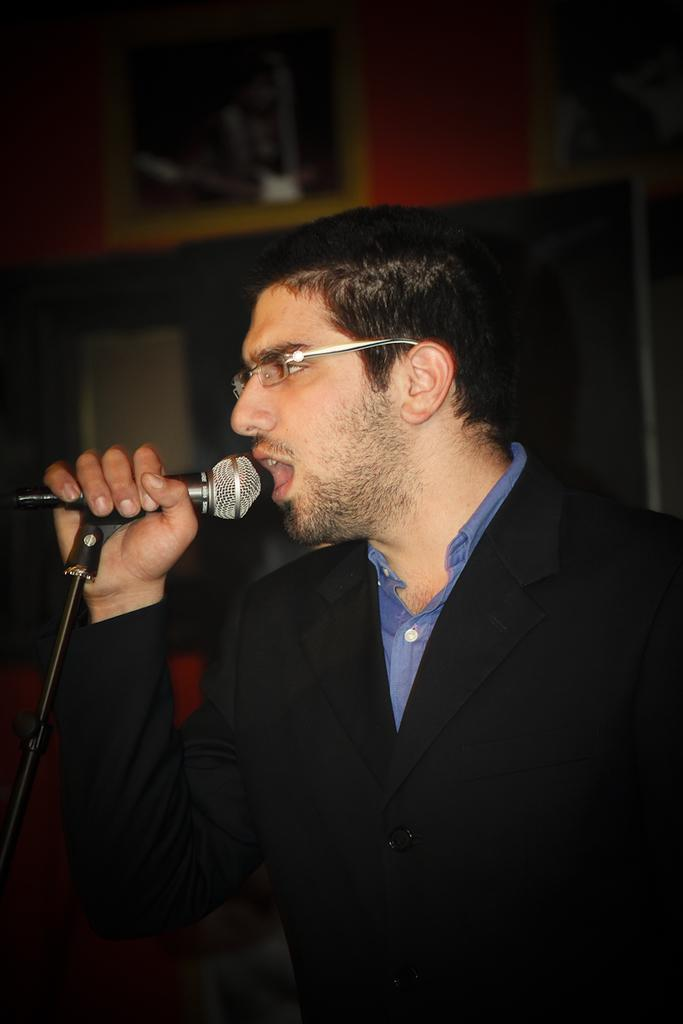Who is the main subject in the image? There is a man in the image. What is the man holding in the image? The man is holding a microphone. What is the man doing with the microphone? The man is speaking into the microphone. What type of bread is the man using to process the growth in the image? There is no bread, processing, or growth present in the image. The man is simply holding and speaking into a microphone. 